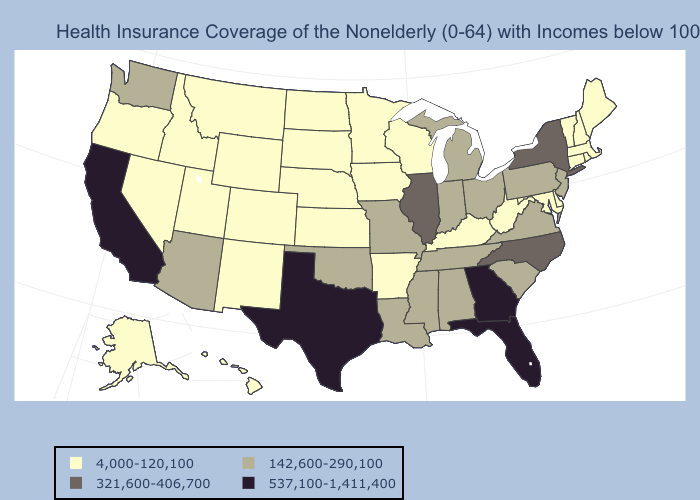Which states have the lowest value in the USA?
Short answer required. Alaska, Arkansas, Colorado, Connecticut, Delaware, Hawaii, Idaho, Iowa, Kansas, Kentucky, Maine, Maryland, Massachusetts, Minnesota, Montana, Nebraska, Nevada, New Hampshire, New Mexico, North Dakota, Oregon, Rhode Island, South Dakota, Utah, Vermont, West Virginia, Wisconsin, Wyoming. Does Utah have a lower value than New Mexico?
Concise answer only. No. Name the states that have a value in the range 321,600-406,700?
Concise answer only. Illinois, New York, North Carolina. Does Georgia have the highest value in the USA?
Short answer required. Yes. Name the states that have a value in the range 142,600-290,100?
Short answer required. Alabama, Arizona, Indiana, Louisiana, Michigan, Mississippi, Missouri, New Jersey, Ohio, Oklahoma, Pennsylvania, South Carolina, Tennessee, Virginia, Washington. What is the highest value in the West ?
Quick response, please. 537,100-1,411,400. How many symbols are there in the legend?
Concise answer only. 4. What is the highest value in states that border New York?
Be succinct. 142,600-290,100. Which states have the highest value in the USA?
Concise answer only. California, Florida, Georgia, Texas. Does Delaware have the lowest value in the USA?
Concise answer only. Yes. What is the highest value in states that border Washington?
Write a very short answer. 4,000-120,100. Does the map have missing data?
Short answer required. No. Does the first symbol in the legend represent the smallest category?
Keep it brief. Yes. What is the highest value in the West ?
Be succinct. 537,100-1,411,400. 